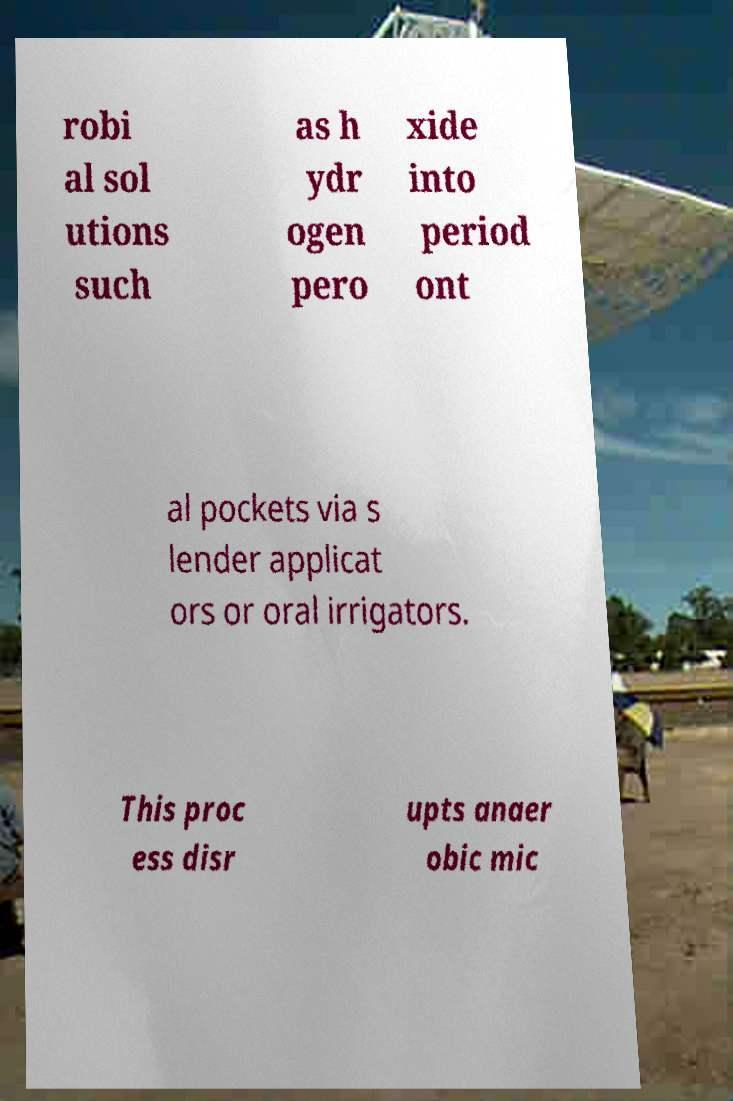Could you extract and type out the text from this image? robi al sol utions such as h ydr ogen pero xide into period ont al pockets via s lender applicat ors or oral irrigators. This proc ess disr upts anaer obic mic 